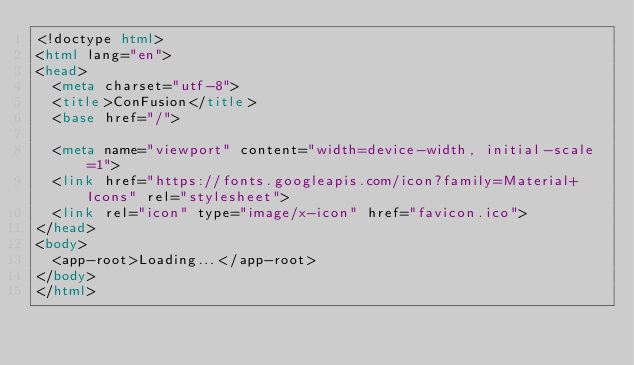Convert code to text. <code><loc_0><loc_0><loc_500><loc_500><_HTML_><!doctype html>
<html lang="en">
<head>
  <meta charset="utf-8">
  <title>ConFusion</title>
  <base href="/">

  <meta name="viewport" content="width=device-width, initial-scale=1">
  <link href="https://fonts.googleapis.com/icon?family=Material+Icons" rel="stylesheet">
  <link rel="icon" type="image/x-icon" href="favicon.ico">
</head>
<body>
  <app-root>Loading...</app-root>
</body>
</html>
</code> 